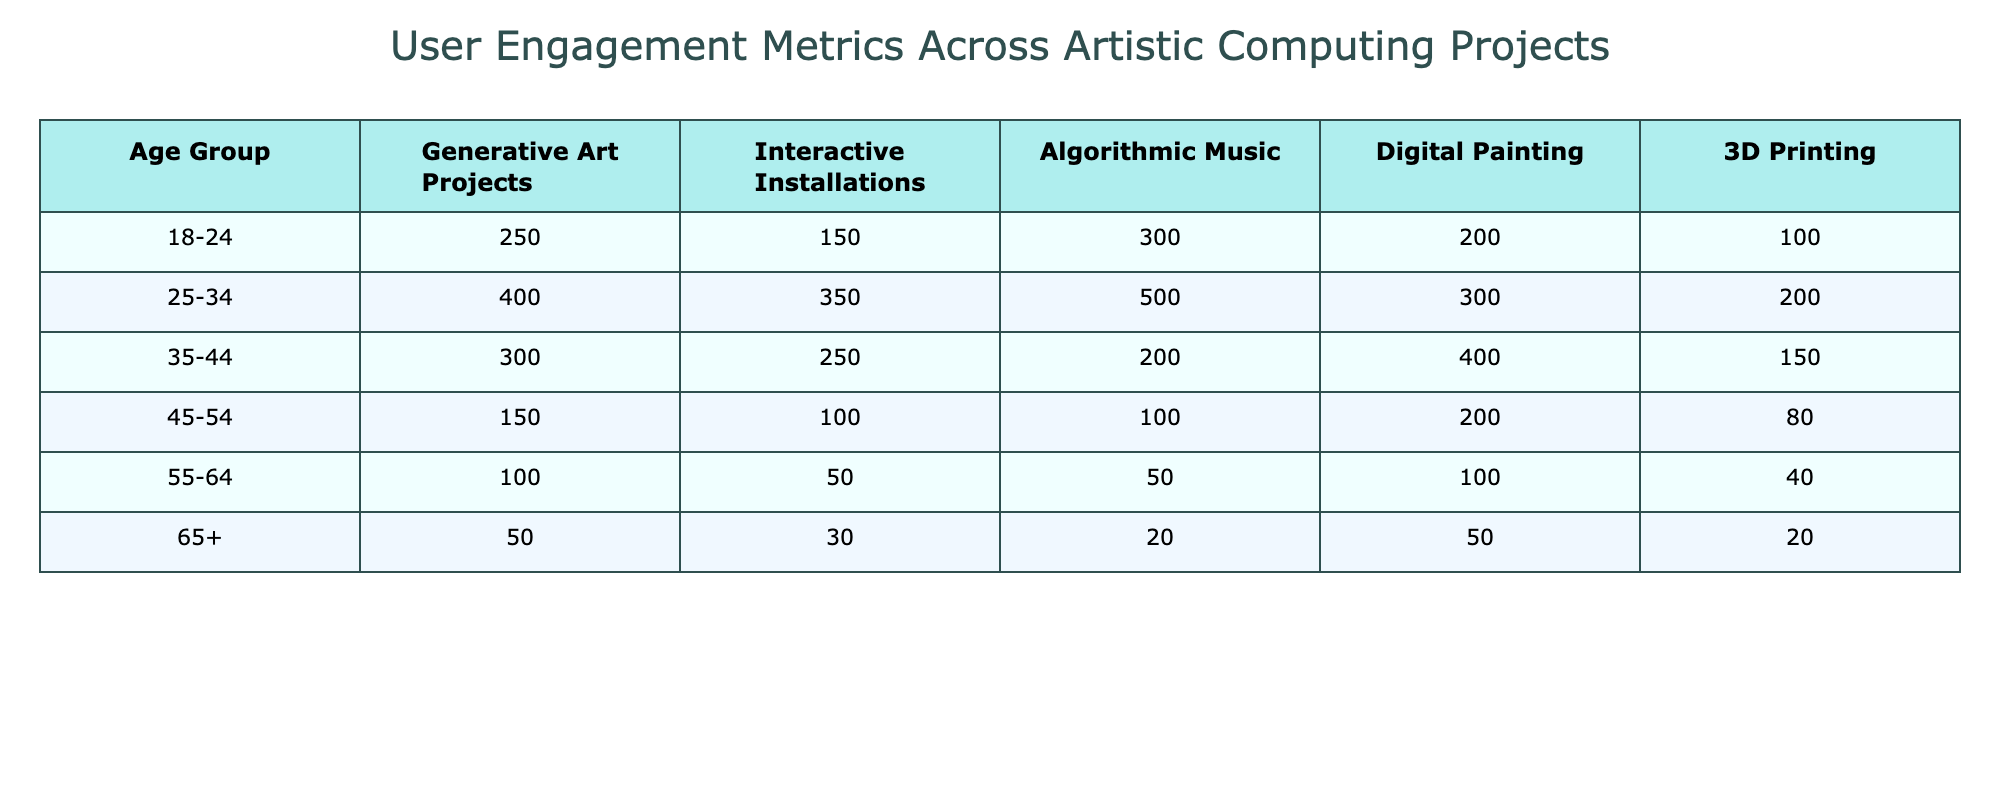What's the highest user engagement for 25-34 age group projects? Looking at the 25-34 age group's engagement metrics, the highest value is found in Algorithmic Music with a score of 500.
Answer: 500 Which project had the least engagement from the 55-64 age group? In the 55-64 age group, the project with the least engagement is 3D Printing with a score of 40.
Answer: 40 What is the total engagement for Generative Art Projects across all age groups? To find the total, we sum up the values: 250 + 400 + 300 + 150 + 100 + 50 = 1250.
Answer: 1250 Is the engagement for Interactive Installations higher among the 18-24 age group than the 45-54 age group? The engagement for the 18-24 age group is 150, while for the 45-54 age group it is 100, so yes, it is higher.
Answer: Yes What is the difference in engagement for Digital Painting between the 35-44 age group and the 55-64 age group? From the 35-44 age group, the engagement is 400, and for the 55-64 age group, it is 100. The difference is 400 - 100 = 300.
Answer: 300 How many age groups have an engagement of more than 200 for Algorithmic Music? The engagement scores greater than 200 for Algorithmic Music are found in the 18-24 (300), 25-34 (500), and 35-44 (200) age groups, making a total of 3 age groups.
Answer: 3 What is the average engagement for 45-54 age group across all projects? For the 45-54 age group, the engagements are 150, 100, 100, 200, and 80. Summing up gives 630, and dividing by 5 (number of projects) gives 630/5 = 126.
Answer: 126 Is there any age group where engagement for 3D Printing exceeds 100? Yes, the 18-24 age group has an engagement of 100, and the 25-34 age group has 200 which exceeds 100.
Answer: Yes 